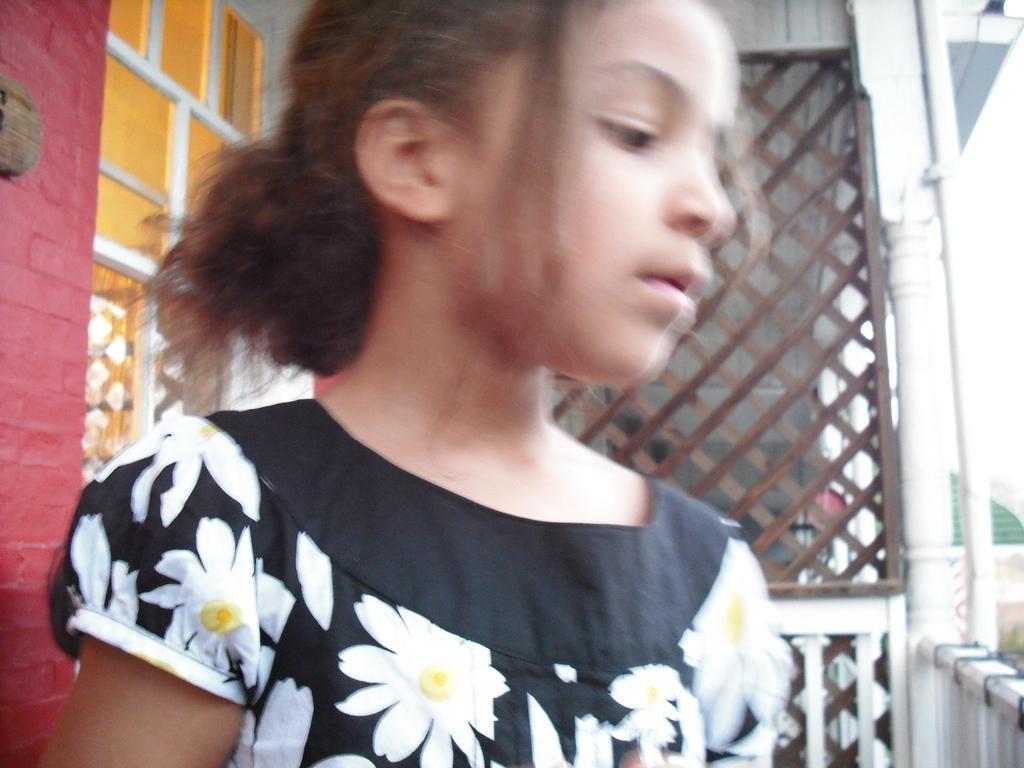Describe this image in one or two sentences. In the foreground of the picture there is a girl. On the left there is a window and wall. In the background there is mesh. On the right it is raining and pillar. 